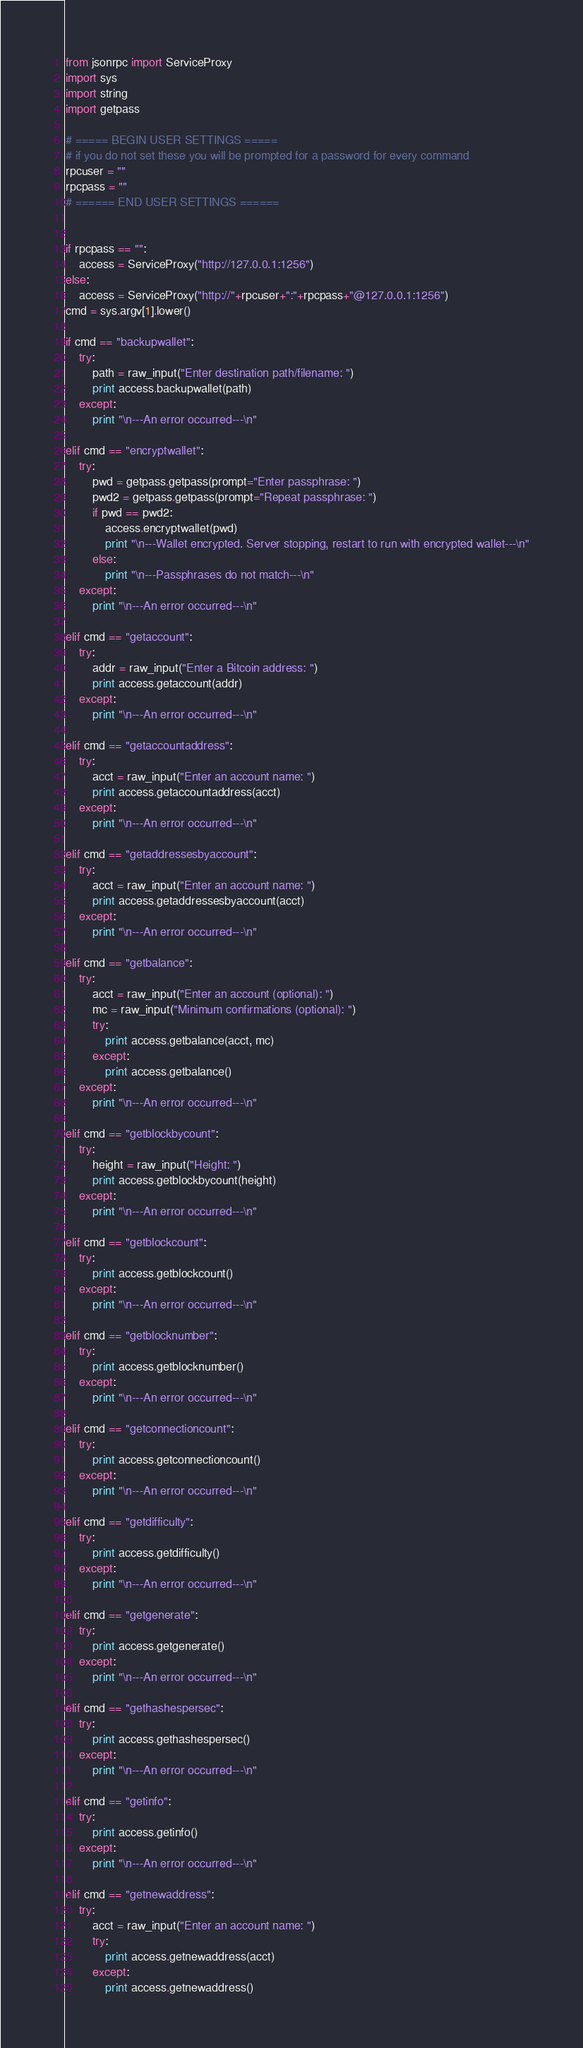<code> <loc_0><loc_0><loc_500><loc_500><_Python_>from jsonrpc import ServiceProxy
import sys
import string
import getpass

# ===== BEGIN USER SETTINGS =====
# if you do not set these you will be prompted for a password for every command
rpcuser = ""
rpcpass = ""
# ====== END USER SETTINGS ======


if rpcpass == "":
    access = ServiceProxy("http://127.0.0.1:1256")
else:
    access = ServiceProxy("http://"+rpcuser+":"+rpcpass+"@127.0.0.1:1256")
cmd = sys.argv[1].lower()

if cmd == "backupwallet":
    try:
        path = raw_input("Enter destination path/filename: ")
        print access.backupwallet(path)
    except:
        print "\n---An error occurred---\n"
        
elif cmd == "encryptwallet":
    try:
        pwd = getpass.getpass(prompt="Enter passphrase: ")
        pwd2 = getpass.getpass(prompt="Repeat passphrase: ")
        if pwd == pwd2:
            access.encryptwallet(pwd)
            print "\n---Wallet encrypted. Server stopping, restart to run with encrypted wallet---\n"
        else:
            print "\n---Passphrases do not match---\n"
    except:
        print "\n---An error occurred---\n"

elif cmd == "getaccount":
    try:
        addr = raw_input("Enter a Bitcoin address: ")
        print access.getaccount(addr)
    except:
        print "\n---An error occurred---\n"

elif cmd == "getaccountaddress":
    try:
        acct = raw_input("Enter an account name: ")
        print access.getaccountaddress(acct)
    except:
        print "\n---An error occurred---\n"

elif cmd == "getaddressesbyaccount":
    try:
        acct = raw_input("Enter an account name: ")
        print access.getaddressesbyaccount(acct)
    except:
        print "\n---An error occurred---\n"

elif cmd == "getbalance":
    try:
        acct = raw_input("Enter an account (optional): ")
        mc = raw_input("Minimum confirmations (optional): ")
        try:
            print access.getbalance(acct, mc)
        except:
            print access.getbalance()
    except:
        print "\n---An error occurred---\n"

elif cmd == "getblockbycount":
    try:
        height = raw_input("Height: ")
        print access.getblockbycount(height)
    except:
        print "\n---An error occurred---\n"

elif cmd == "getblockcount":
    try:
        print access.getblockcount()
    except:
        print "\n---An error occurred---\n"

elif cmd == "getblocknumber":
    try:
        print access.getblocknumber()
    except:
        print "\n---An error occurred---\n"

elif cmd == "getconnectioncount":
    try:
        print access.getconnectioncount()
    except:
        print "\n---An error occurred---\n"

elif cmd == "getdifficulty":
    try:
        print access.getdifficulty()
    except:
        print "\n---An error occurred---\n"

elif cmd == "getgenerate":
    try:
        print access.getgenerate()
    except:
        print "\n---An error occurred---\n"

elif cmd == "gethashespersec":
    try:
        print access.gethashespersec()
    except:
        print "\n---An error occurred---\n"

elif cmd == "getinfo":
    try:
        print access.getinfo()
    except:
        print "\n---An error occurred---\n"

elif cmd == "getnewaddress":
    try:
        acct = raw_input("Enter an account name: ")
        try:
            print access.getnewaddress(acct)
        except:
            print access.getnewaddress()</code> 